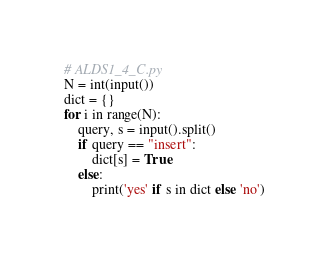Convert code to text. <code><loc_0><loc_0><loc_500><loc_500><_Python_># ALDS1_4_C.py
N = int(input())
dict = {}
for i in range(N):
    query, s = input().split()
    if query == "insert":
        dict[s] = True
    else:
        print('yes' if s in dict else 'no')

</code> 